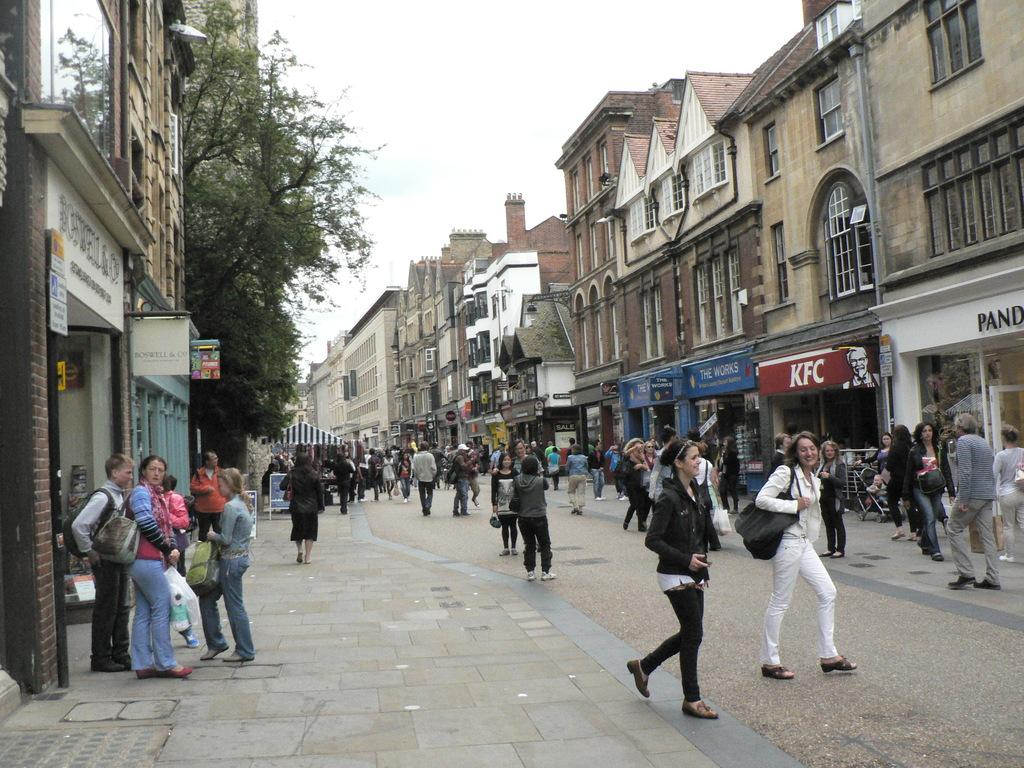Who or what can be seen in the image? There are people in the image. What type of natural elements are present in the image? There are trees in the image. What type of man-made structures are present in the image? There are buildings in the image. What type of signage is present in the image? There are boards with text in the image. What is the surface on which the people and objects are standing? The ground is visible in the image. What objects can be seen on the ground? There are objects on the ground. What part of the natural environment is visible in the image? The sky is visible in the image. Can you read the caption on the tree in the image? There is no caption on a tree in the image; trees are natural elements without text. 